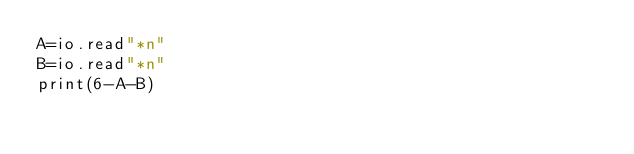<code> <loc_0><loc_0><loc_500><loc_500><_Lua_>A=io.read"*n"
B=io.read"*n"
print(6-A-B)</code> 